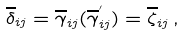<formula> <loc_0><loc_0><loc_500><loc_500>\overline { \delta } _ { i j } = \overline { \gamma } _ { i j } ( \overline { \gamma } _ { i j } ^ { ^ { \prime } } ) = \overline { \zeta } _ { i j } \, ,</formula> 